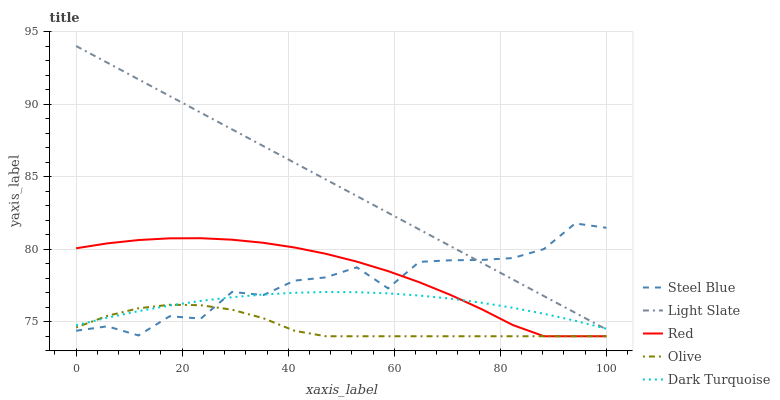Does Olive have the minimum area under the curve?
Answer yes or no. Yes. Does Light Slate have the maximum area under the curve?
Answer yes or no. Yes. Does Steel Blue have the minimum area under the curve?
Answer yes or no. No. Does Steel Blue have the maximum area under the curve?
Answer yes or no. No. Is Light Slate the smoothest?
Answer yes or no. Yes. Is Steel Blue the roughest?
Answer yes or no. Yes. Is Olive the smoothest?
Answer yes or no. No. Is Olive the roughest?
Answer yes or no. No. Does Olive have the lowest value?
Answer yes or no. Yes. Does Steel Blue have the lowest value?
Answer yes or no. No. Does Light Slate have the highest value?
Answer yes or no. Yes. Does Steel Blue have the highest value?
Answer yes or no. No. Is Olive less than Light Slate?
Answer yes or no. Yes. Is Light Slate greater than Red?
Answer yes or no. Yes. Does Dark Turquoise intersect Steel Blue?
Answer yes or no. Yes. Is Dark Turquoise less than Steel Blue?
Answer yes or no. No. Is Dark Turquoise greater than Steel Blue?
Answer yes or no. No. Does Olive intersect Light Slate?
Answer yes or no. No. 